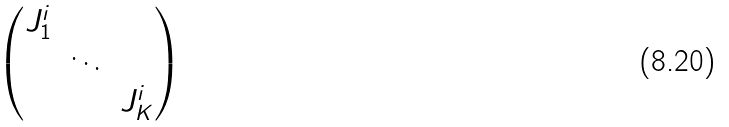Convert formula to latex. <formula><loc_0><loc_0><loc_500><loc_500>\begin{pmatrix} J _ { 1 } ^ { i } & & \\ & \ddots & \\ & & J ^ { i } _ { K } \end{pmatrix}</formula> 